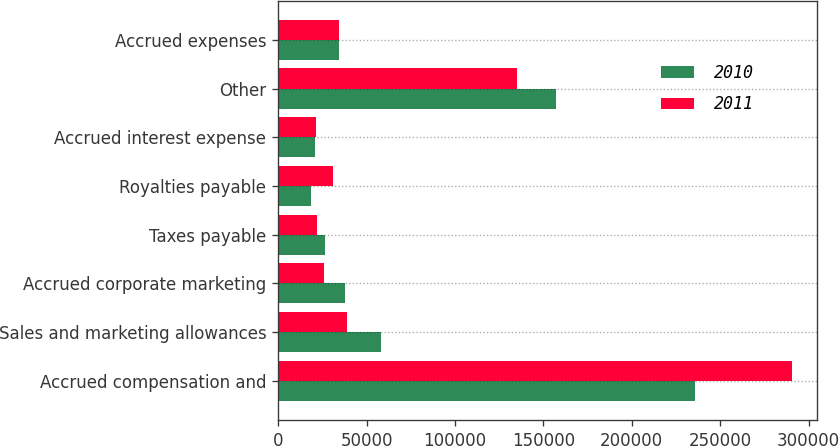Convert chart to OTSL. <chart><loc_0><loc_0><loc_500><loc_500><stacked_bar_chart><ecel><fcel>Accrued compensation and<fcel>Sales and marketing allowances<fcel>Accrued corporate marketing<fcel>Taxes payable<fcel>Royalties payable<fcel>Accrued interest expense<fcel>Other<fcel>Accrued expenses<nl><fcel>2010<fcel>235500<fcel>58156<fcel>37757<fcel>26732<fcel>18778<fcel>21010<fcel>157008<fcel>34382<nl><fcel>2011<fcel>290366<fcel>38706<fcel>26190<fcel>21800<fcel>31007<fcel>21203<fcel>135003<fcel>34382<nl></chart> 